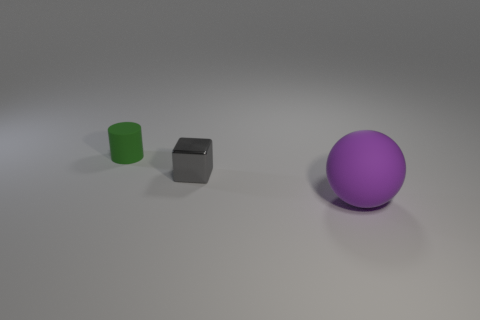Is there any other thing that has the same size as the rubber sphere?
Make the answer very short. No. Is there anything else that is the same shape as the big thing?
Your answer should be compact. No. Do the object that is right of the gray metallic thing and the green cylinder have the same material?
Offer a very short reply. Yes. How many objects are matte things that are left of the small gray shiny object or large green shiny things?
Give a very brief answer. 1. What is the color of the small cylinder that is made of the same material as the purple ball?
Offer a terse response. Green. Is there a green cylinder that has the same size as the gray metal block?
Ensure brevity in your answer.  Yes. What color is the object that is to the left of the large purple matte sphere and in front of the small cylinder?
Give a very brief answer. Gray. There is another object that is the same size as the green object; what shape is it?
Provide a succinct answer. Cube. Are there any small blue shiny objects that have the same shape as the gray metal object?
Offer a very short reply. No. Does the rubber object that is on the left side of the gray block have the same size as the gray metal object?
Your answer should be very brief. Yes. 